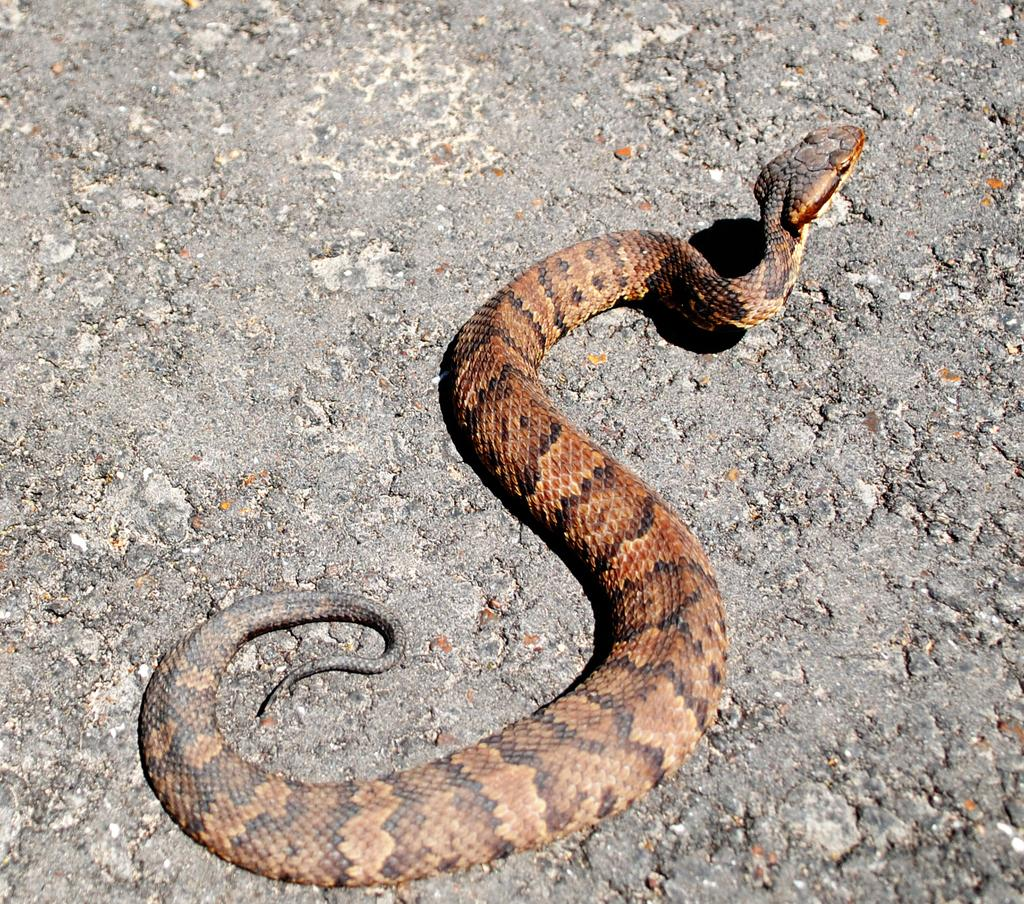What type of animal is present in the image? There is a snake in the image. What is located at the bottom of the image? There is a road at the bottom of the image. What type of polish is being applied to the yard in the image? There is no mention of polish or a yard in the image; it features a snake and a road. 